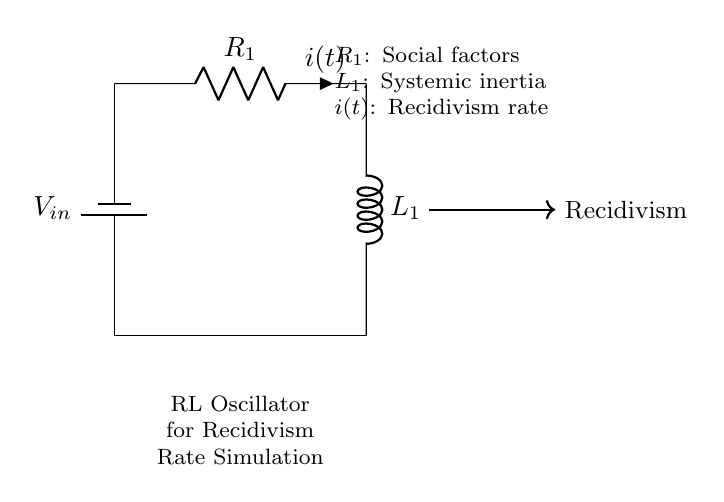What type of components are in this circuit? The circuit contains a resistor and an inductor, which are the primary components of an RL circuit. Both are essential for determining the oscillatory behavior in the system.
Answer: resistor and inductor What does R1 represent in the circuit? R1 denotes social factors influencing the recidivism rate, as described in the circuit's annotation, linking the electrical component to a social concept.
Answer: social factors What does L1 signify in the circuit? L1 symbolizes systemic inertia, relating it to the resistance encountered in social systems when it comes to changing recidivism behaviors. This reinforces the analogy between electrical and social systems.
Answer: systemic inertia What is the significance of current i(t) in this circuit? The current i(t) represents the recidivism rate over time, showcasing how it fluctuates based on social factors and systemic inertia present in the RL circuit.
Answer: recidivism rate How can you interpret the relationship between R1 and L1 in this circuit? R1 and L1 together affect the oscillation frequency of the circuit, indicating that social influences and systemic inertia interact to produce varying recidivism patterns. Their values can dictate how quickly or slowly these oscillations occur.
Answer: influence dynamics What kind of circuit is this classified as? This circuit is classified as an RL oscillator, which specifically refers to circuits that involve resistors and inductors to produce oscillatory behavior in the currents.
Answer: RL oscillator How does this circuit relate to simulating recidivism rates? The circuit simulates recidivism rates by using the oscillation patterns generated by the R1 and L1 components, allowing researchers to model how different social factors and inertia can lead to varying recidivism behaviors over time.
Answer: simulating recidivism patterns 